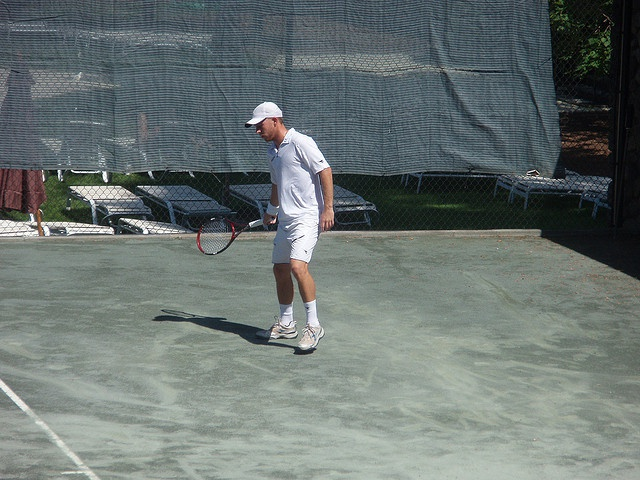Describe the objects in this image and their specific colors. I can see people in gray, lightgray, and darkgray tones, chair in gray and darkgray tones, tennis racket in gray, black, and darkgray tones, chair in gray, lightgray, black, and darkgray tones, and chair in gray and purple tones in this image. 